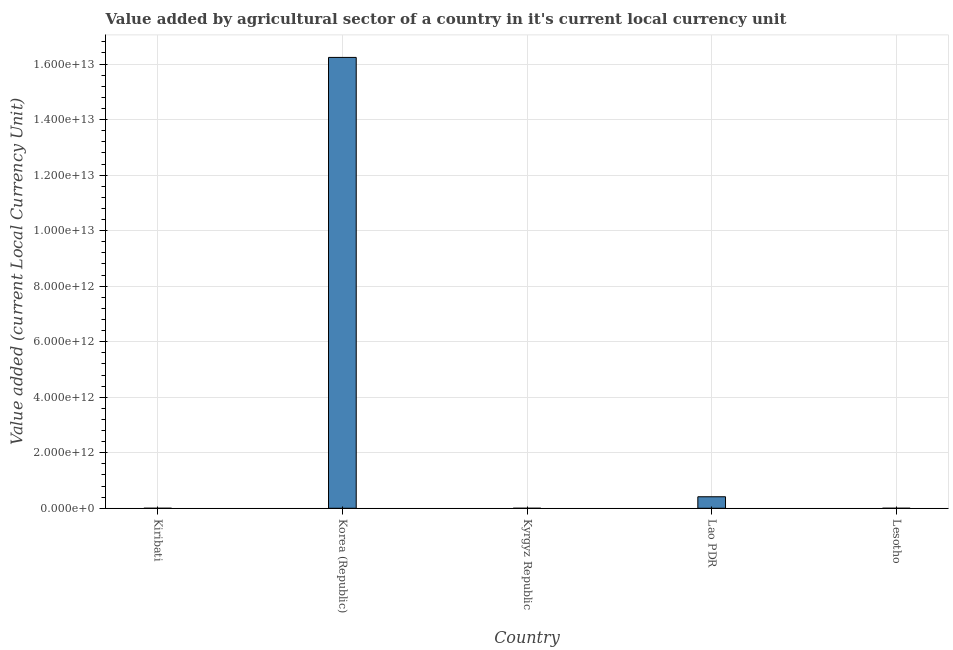Does the graph contain grids?
Your response must be concise. Yes. What is the title of the graph?
Your response must be concise. Value added by agricultural sector of a country in it's current local currency unit. What is the label or title of the X-axis?
Keep it short and to the point. Country. What is the label or title of the Y-axis?
Offer a terse response. Value added (current Local Currency Unit). What is the value added by agriculture sector in Lesotho?
Provide a succinct answer. 2.69e+08. Across all countries, what is the maximum value added by agriculture sector?
Your answer should be compact. 1.62e+13. Across all countries, what is the minimum value added by agriculture sector?
Offer a terse response. 1.64e+07. In which country was the value added by agriculture sector minimum?
Ensure brevity in your answer.  Kiribati. What is the sum of the value added by agriculture sector?
Provide a short and direct response. 1.67e+13. What is the difference between the value added by agriculture sector in Korea (Republic) and Lesotho?
Your answer should be very brief. 1.62e+13. What is the average value added by agriculture sector per country?
Provide a succinct answer. 3.33e+12. What is the median value added by agriculture sector?
Your answer should be very brief. 2.69e+08. In how many countries, is the value added by agriculture sector greater than 4800000000000 LCU?
Provide a succinct answer. 1. What is the ratio of the value added by agriculture sector in Kiribati to that in Kyrgyz Republic?
Offer a terse response. 0.5. Is the difference between the value added by agriculture sector in Kiribati and Kyrgyz Republic greater than the difference between any two countries?
Ensure brevity in your answer.  No. What is the difference between the highest and the second highest value added by agriculture sector?
Provide a short and direct response. 1.58e+13. Is the sum of the value added by agriculture sector in Kiribati and Lao PDR greater than the maximum value added by agriculture sector across all countries?
Offer a very short reply. No. What is the difference between the highest and the lowest value added by agriculture sector?
Ensure brevity in your answer.  1.62e+13. In how many countries, is the value added by agriculture sector greater than the average value added by agriculture sector taken over all countries?
Your answer should be compact. 1. How many bars are there?
Keep it short and to the point. 5. Are all the bars in the graph horizontal?
Give a very brief answer. No. What is the difference between two consecutive major ticks on the Y-axis?
Your answer should be compact. 2.00e+12. Are the values on the major ticks of Y-axis written in scientific E-notation?
Offer a terse response. Yes. What is the Value added (current Local Currency Unit) of Kiribati?
Provide a short and direct response. 1.64e+07. What is the Value added (current Local Currency Unit) of Korea (Republic)?
Provide a short and direct response. 1.62e+13. What is the Value added (current Local Currency Unit) in Kyrgyz Republic?
Give a very brief answer. 3.26e+07. What is the Value added (current Local Currency Unit) in Lao PDR?
Provide a short and direct response. 4.14e+11. What is the Value added (current Local Currency Unit) of Lesotho?
Provide a succinct answer. 2.69e+08. What is the difference between the Value added (current Local Currency Unit) in Kiribati and Korea (Republic)?
Ensure brevity in your answer.  -1.62e+13. What is the difference between the Value added (current Local Currency Unit) in Kiribati and Kyrgyz Republic?
Provide a succinct answer. -1.63e+07. What is the difference between the Value added (current Local Currency Unit) in Kiribati and Lao PDR?
Offer a terse response. -4.14e+11. What is the difference between the Value added (current Local Currency Unit) in Kiribati and Lesotho?
Your response must be concise. -2.53e+08. What is the difference between the Value added (current Local Currency Unit) in Korea (Republic) and Kyrgyz Republic?
Give a very brief answer. 1.62e+13. What is the difference between the Value added (current Local Currency Unit) in Korea (Republic) and Lao PDR?
Keep it short and to the point. 1.58e+13. What is the difference between the Value added (current Local Currency Unit) in Korea (Republic) and Lesotho?
Your response must be concise. 1.62e+13. What is the difference between the Value added (current Local Currency Unit) in Kyrgyz Republic and Lao PDR?
Offer a very short reply. -4.14e+11. What is the difference between the Value added (current Local Currency Unit) in Kyrgyz Republic and Lesotho?
Give a very brief answer. -2.37e+08. What is the difference between the Value added (current Local Currency Unit) in Lao PDR and Lesotho?
Offer a terse response. 4.14e+11. What is the ratio of the Value added (current Local Currency Unit) in Kiribati to that in Kyrgyz Republic?
Make the answer very short. 0.5. What is the ratio of the Value added (current Local Currency Unit) in Kiribati to that in Lao PDR?
Your answer should be very brief. 0. What is the ratio of the Value added (current Local Currency Unit) in Kiribati to that in Lesotho?
Keep it short and to the point. 0.06. What is the ratio of the Value added (current Local Currency Unit) in Korea (Republic) to that in Kyrgyz Republic?
Your answer should be compact. 4.98e+05. What is the ratio of the Value added (current Local Currency Unit) in Korea (Republic) to that in Lao PDR?
Your answer should be compact. 39.18. What is the ratio of the Value added (current Local Currency Unit) in Korea (Republic) to that in Lesotho?
Your answer should be compact. 6.03e+04. What is the ratio of the Value added (current Local Currency Unit) in Kyrgyz Republic to that in Lao PDR?
Your answer should be very brief. 0. What is the ratio of the Value added (current Local Currency Unit) in Kyrgyz Republic to that in Lesotho?
Offer a terse response. 0.12. What is the ratio of the Value added (current Local Currency Unit) in Lao PDR to that in Lesotho?
Ensure brevity in your answer.  1539.18. 